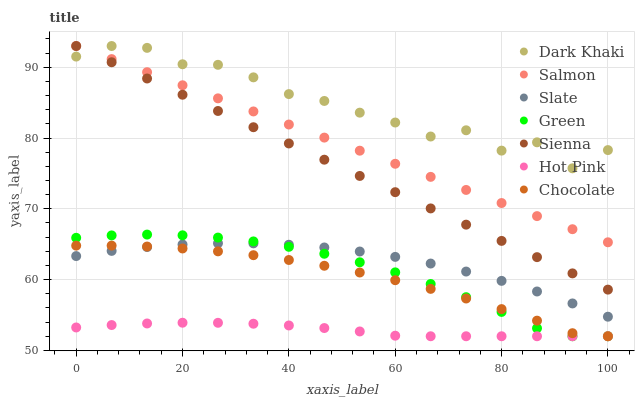Does Hot Pink have the minimum area under the curve?
Answer yes or no. Yes. Does Dark Khaki have the maximum area under the curve?
Answer yes or no. Yes. Does Slate have the minimum area under the curve?
Answer yes or no. No. Does Slate have the maximum area under the curve?
Answer yes or no. No. Is Sienna the smoothest?
Answer yes or no. Yes. Is Dark Khaki the roughest?
Answer yes or no. Yes. Is Slate the smoothest?
Answer yes or no. No. Is Slate the roughest?
Answer yes or no. No. Does Hot Pink have the lowest value?
Answer yes or no. Yes. Does Slate have the lowest value?
Answer yes or no. No. Does Dark Khaki have the highest value?
Answer yes or no. Yes. Does Slate have the highest value?
Answer yes or no. No. Is Hot Pink less than Sienna?
Answer yes or no. Yes. Is Sienna greater than Hot Pink?
Answer yes or no. Yes. Does Chocolate intersect Green?
Answer yes or no. Yes. Is Chocolate less than Green?
Answer yes or no. No. Is Chocolate greater than Green?
Answer yes or no. No. Does Hot Pink intersect Sienna?
Answer yes or no. No. 